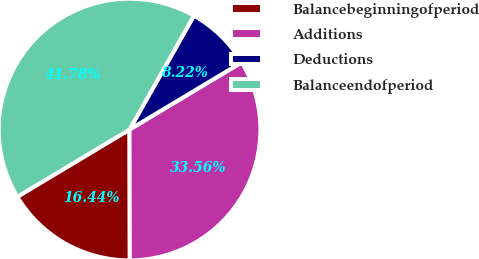Convert chart. <chart><loc_0><loc_0><loc_500><loc_500><pie_chart><fcel>Balancebeginningofperiod<fcel>Additions<fcel>Deductions<fcel>Balanceendofperiod<nl><fcel>16.44%<fcel>33.56%<fcel>8.22%<fcel>41.78%<nl></chart> 